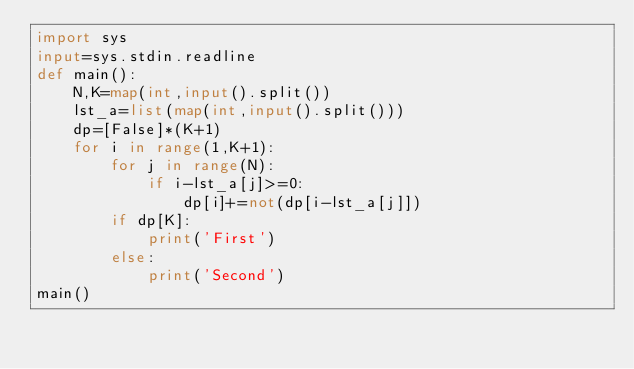<code> <loc_0><loc_0><loc_500><loc_500><_Python_>import sys
input=sys.stdin.readline
def main():
    N,K=map(int,input().split())
    lst_a=list(map(int,input().split()))
    dp=[False]*(K+1)
    for i in range(1,K+1):
        for j in range(N):
            if i-lst_a[j]>=0:
                dp[i]+=not(dp[i-lst_a[j]])
        if dp[K]:
            print('First')
        else:
            print('Second')
main()</code> 